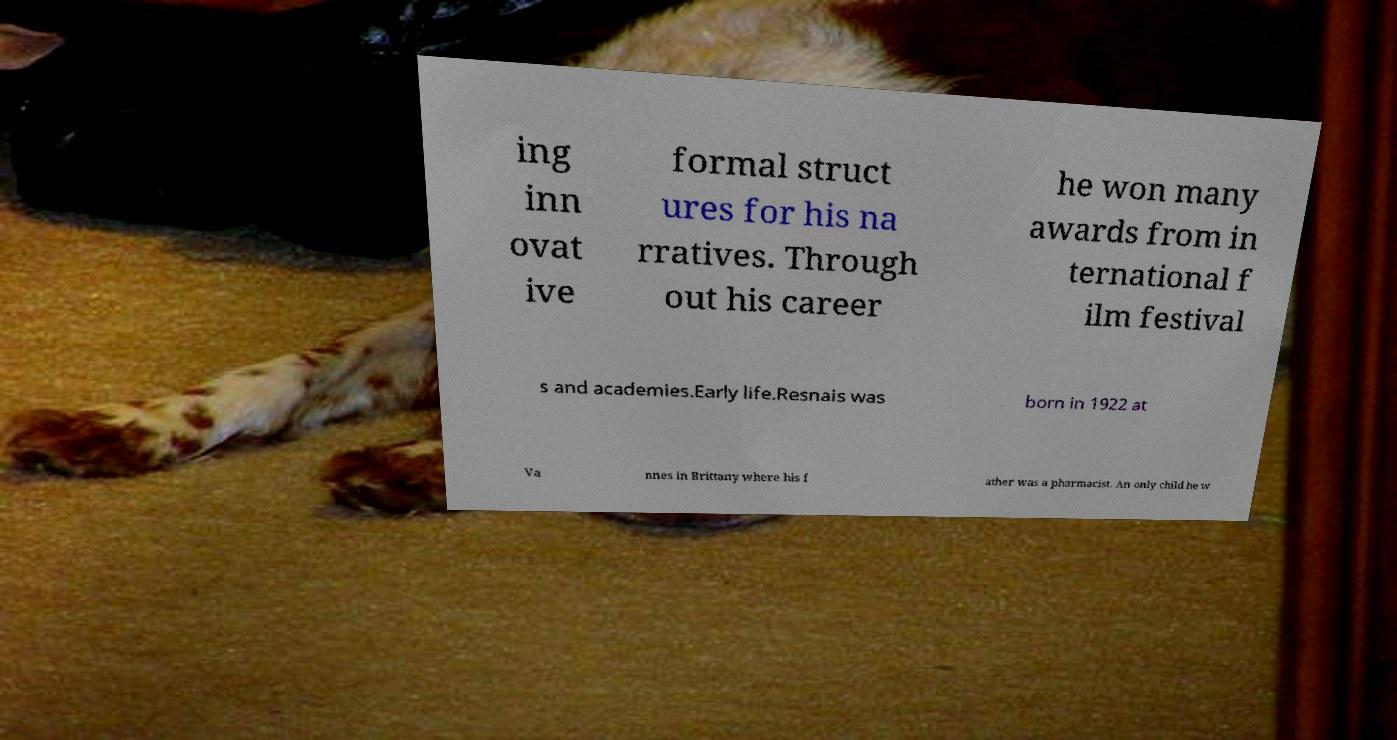Could you extract and type out the text from this image? ing inn ovat ive formal struct ures for his na rratives. Through out his career he won many awards from in ternational f ilm festival s and academies.Early life.Resnais was born in 1922 at Va nnes in Brittany where his f ather was a pharmacist. An only child he w 